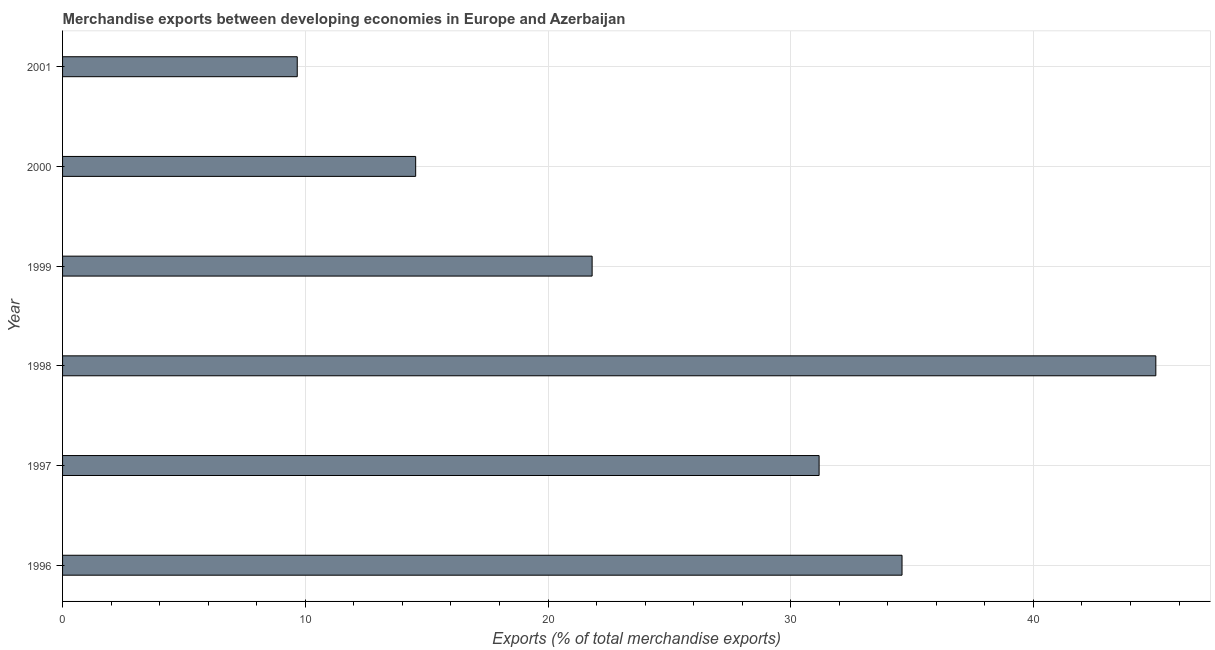Does the graph contain any zero values?
Your response must be concise. No. What is the title of the graph?
Provide a short and direct response. Merchandise exports between developing economies in Europe and Azerbaijan. What is the label or title of the X-axis?
Offer a terse response. Exports (% of total merchandise exports). What is the label or title of the Y-axis?
Provide a succinct answer. Year. What is the merchandise exports in 2000?
Your response must be concise. 14.55. Across all years, what is the maximum merchandise exports?
Provide a short and direct response. 45.04. Across all years, what is the minimum merchandise exports?
Your response must be concise. 9.67. In which year was the merchandise exports maximum?
Your answer should be very brief. 1998. In which year was the merchandise exports minimum?
Provide a succinct answer. 2001. What is the sum of the merchandise exports?
Make the answer very short. 156.83. What is the difference between the merchandise exports in 1996 and 1997?
Your answer should be very brief. 3.42. What is the average merchandise exports per year?
Keep it short and to the point. 26.14. What is the median merchandise exports?
Ensure brevity in your answer.  26.49. In how many years, is the merchandise exports greater than 4 %?
Your response must be concise. 6. What is the ratio of the merchandise exports in 1999 to that in 2001?
Give a very brief answer. 2.26. Is the merchandise exports in 1996 less than that in 1999?
Your answer should be very brief. No. Is the difference between the merchandise exports in 1997 and 2000 greater than the difference between any two years?
Ensure brevity in your answer.  No. What is the difference between the highest and the second highest merchandise exports?
Offer a very short reply. 10.46. Is the sum of the merchandise exports in 1996 and 2001 greater than the maximum merchandise exports across all years?
Your response must be concise. No. What is the difference between the highest and the lowest merchandise exports?
Provide a short and direct response. 35.37. In how many years, is the merchandise exports greater than the average merchandise exports taken over all years?
Your response must be concise. 3. How many bars are there?
Your response must be concise. 6. Are all the bars in the graph horizontal?
Provide a succinct answer. Yes. How many years are there in the graph?
Provide a succinct answer. 6. Are the values on the major ticks of X-axis written in scientific E-notation?
Provide a short and direct response. No. What is the Exports (% of total merchandise exports) of 1996?
Offer a terse response. 34.59. What is the Exports (% of total merchandise exports) of 1997?
Provide a succinct answer. 31.17. What is the Exports (% of total merchandise exports) of 1998?
Provide a succinct answer. 45.04. What is the Exports (% of total merchandise exports) in 1999?
Your answer should be compact. 21.82. What is the Exports (% of total merchandise exports) of 2000?
Make the answer very short. 14.55. What is the Exports (% of total merchandise exports) of 2001?
Provide a short and direct response. 9.67. What is the difference between the Exports (% of total merchandise exports) in 1996 and 1997?
Offer a terse response. 3.42. What is the difference between the Exports (% of total merchandise exports) in 1996 and 1998?
Your answer should be compact. -10.46. What is the difference between the Exports (% of total merchandise exports) in 1996 and 1999?
Keep it short and to the point. 12.77. What is the difference between the Exports (% of total merchandise exports) in 1996 and 2000?
Give a very brief answer. 20.04. What is the difference between the Exports (% of total merchandise exports) in 1996 and 2001?
Your response must be concise. 24.92. What is the difference between the Exports (% of total merchandise exports) in 1997 and 1998?
Make the answer very short. -13.87. What is the difference between the Exports (% of total merchandise exports) in 1997 and 1999?
Ensure brevity in your answer.  9.35. What is the difference between the Exports (% of total merchandise exports) in 1997 and 2000?
Keep it short and to the point. 16.62. What is the difference between the Exports (% of total merchandise exports) in 1997 and 2001?
Offer a terse response. 21.5. What is the difference between the Exports (% of total merchandise exports) in 1998 and 1999?
Offer a very short reply. 23.22. What is the difference between the Exports (% of total merchandise exports) in 1998 and 2000?
Provide a succinct answer. 30.49. What is the difference between the Exports (% of total merchandise exports) in 1998 and 2001?
Ensure brevity in your answer.  35.37. What is the difference between the Exports (% of total merchandise exports) in 1999 and 2000?
Your answer should be very brief. 7.27. What is the difference between the Exports (% of total merchandise exports) in 1999 and 2001?
Provide a short and direct response. 12.15. What is the difference between the Exports (% of total merchandise exports) in 2000 and 2001?
Provide a succinct answer. 4.88. What is the ratio of the Exports (% of total merchandise exports) in 1996 to that in 1997?
Keep it short and to the point. 1.11. What is the ratio of the Exports (% of total merchandise exports) in 1996 to that in 1998?
Your response must be concise. 0.77. What is the ratio of the Exports (% of total merchandise exports) in 1996 to that in 1999?
Your answer should be very brief. 1.58. What is the ratio of the Exports (% of total merchandise exports) in 1996 to that in 2000?
Ensure brevity in your answer.  2.38. What is the ratio of the Exports (% of total merchandise exports) in 1996 to that in 2001?
Offer a terse response. 3.58. What is the ratio of the Exports (% of total merchandise exports) in 1997 to that in 1998?
Ensure brevity in your answer.  0.69. What is the ratio of the Exports (% of total merchandise exports) in 1997 to that in 1999?
Make the answer very short. 1.43. What is the ratio of the Exports (% of total merchandise exports) in 1997 to that in 2000?
Give a very brief answer. 2.14. What is the ratio of the Exports (% of total merchandise exports) in 1997 to that in 2001?
Give a very brief answer. 3.22. What is the ratio of the Exports (% of total merchandise exports) in 1998 to that in 1999?
Give a very brief answer. 2.06. What is the ratio of the Exports (% of total merchandise exports) in 1998 to that in 2000?
Keep it short and to the point. 3.1. What is the ratio of the Exports (% of total merchandise exports) in 1998 to that in 2001?
Your response must be concise. 4.66. What is the ratio of the Exports (% of total merchandise exports) in 1999 to that in 2000?
Your response must be concise. 1.5. What is the ratio of the Exports (% of total merchandise exports) in 1999 to that in 2001?
Your response must be concise. 2.26. What is the ratio of the Exports (% of total merchandise exports) in 2000 to that in 2001?
Give a very brief answer. 1.5. 